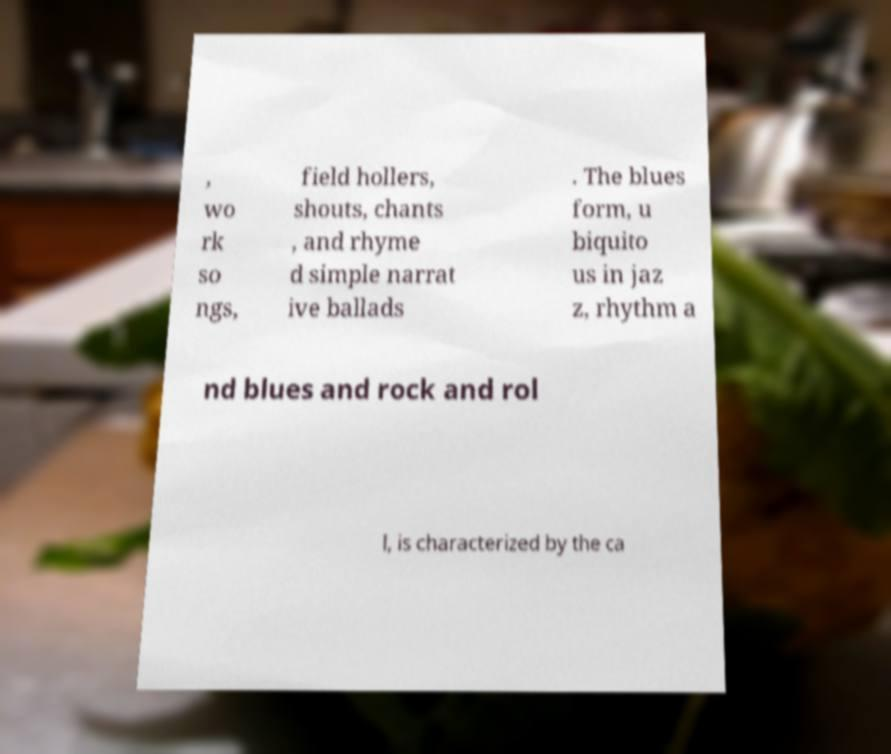I need the written content from this picture converted into text. Can you do that? , wo rk so ngs, field hollers, shouts, chants , and rhyme d simple narrat ive ballads . The blues form, u biquito us in jaz z, rhythm a nd blues and rock and rol l, is characterized by the ca 